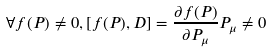<formula> <loc_0><loc_0><loc_500><loc_500>\forall f ( P ) \neq 0 , [ f ( P ) , D ] = \frac { \partial f ( P ) } { \partial P _ { \mu } } P _ { \mu } \neq 0</formula> 